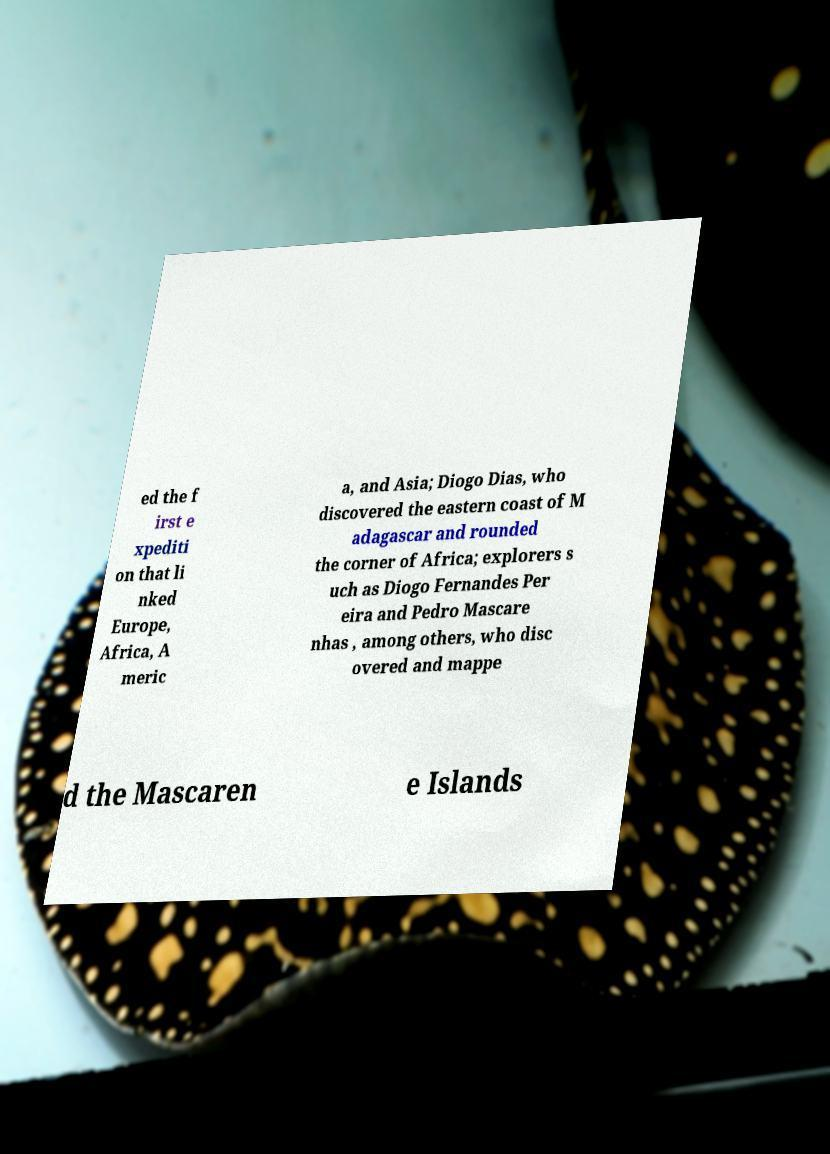Please identify and transcribe the text found in this image. ed the f irst e xpediti on that li nked Europe, Africa, A meric a, and Asia; Diogo Dias, who discovered the eastern coast of M adagascar and rounded the corner of Africa; explorers s uch as Diogo Fernandes Per eira and Pedro Mascare nhas , among others, who disc overed and mappe d the Mascaren e Islands 